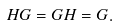Convert formula to latex. <formula><loc_0><loc_0><loc_500><loc_500>H G = G H = G .</formula> 